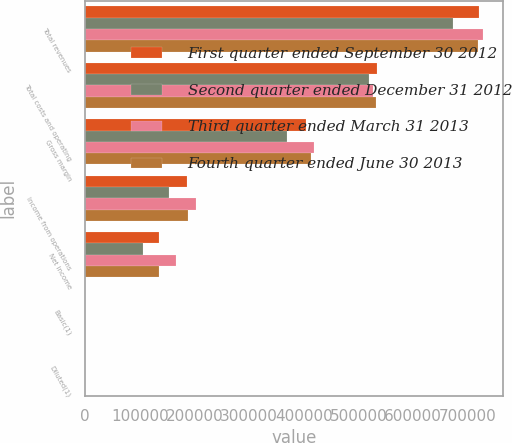Convert chart. <chart><loc_0><loc_0><loc_500><loc_500><stacked_bar_chart><ecel><fcel>Total revenues<fcel>Total costs and operating<fcel>Gross margin<fcel>Income from operations<fcel>Net income<fcel>Basic(1)<fcel>Diluted(1)<nl><fcel>First quarter ended September 30 2012<fcel>720709<fcel>534152<fcel>403484<fcel>186557<fcel>135367<fcel>0.81<fcel>0.8<nl><fcel>Second quarter ended December 31 2012<fcel>673011<fcel>519764<fcel>369096<fcel>153247<fcel>106630<fcel>0.64<fcel>0.63<nl><fcel>Third quarter ended March 31 2013<fcel>729029<fcel>526783<fcel>419521<fcel>202246<fcel>166382<fcel>1<fcel>0.98<nl><fcel>Fourth quarter ended June 30 2013<fcel>720032<fcel>532397<fcel>413228<fcel>187635<fcel>134770<fcel>0.81<fcel>0.8<nl></chart> 